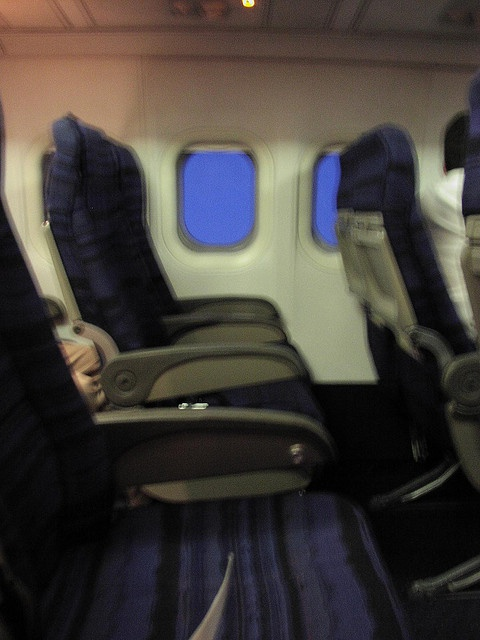Describe the objects in this image and their specific colors. I can see chair in salmon, black, and gray tones, chair in salmon, black, darkgreen, and gray tones, chair in salmon, black, and gray tones, people in salmon, darkgray, black, and gray tones, and people in salmon, tan, and gray tones in this image. 